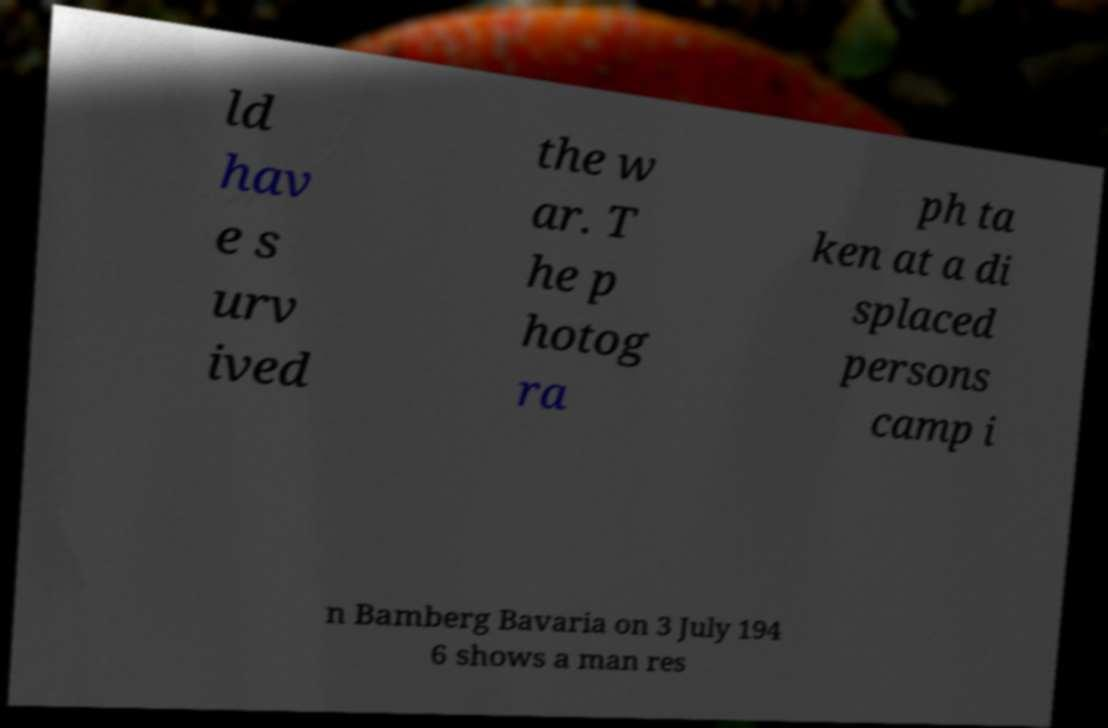Could you assist in decoding the text presented in this image and type it out clearly? ld hav e s urv ived the w ar. T he p hotog ra ph ta ken at a di splaced persons camp i n Bamberg Bavaria on 3 July 194 6 shows a man res 